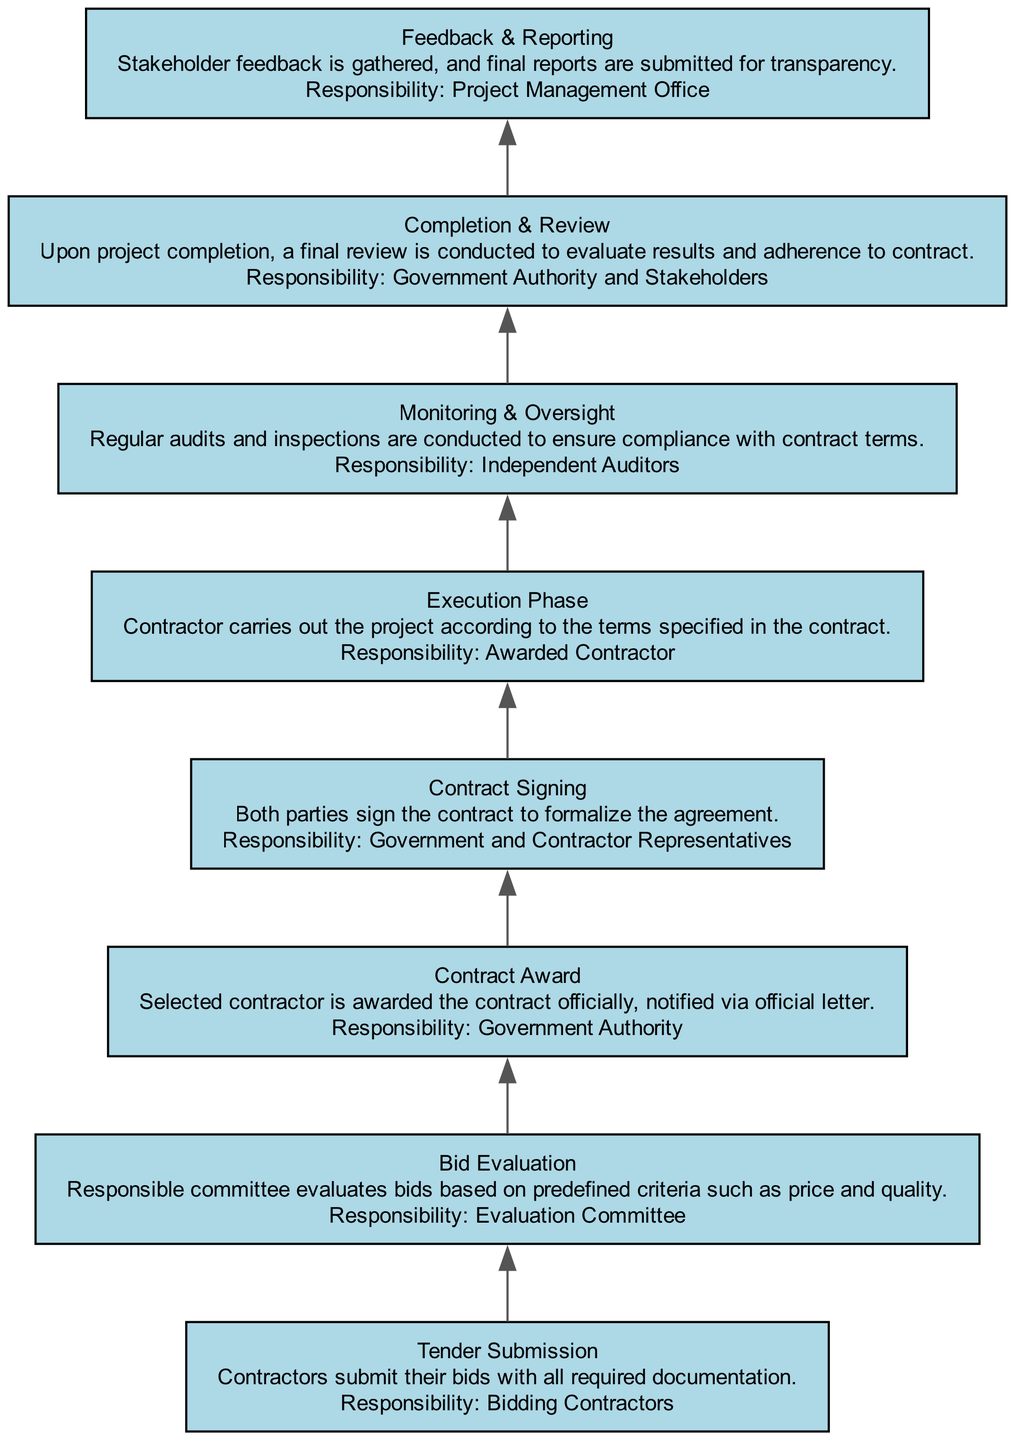What is the first step in the contract process? The diagram starts with "Tender Submission," which indicates that this is the initial step where contractors submit their bids.
Answer: Tender Submission Who is responsible for bid evaluation? The "Evaluation Committee" is designated as responsible for evaluating the bids according to the diagram, indicating their main role in the process.
Answer: Evaluation Committee How many steps are there in the contract process? The diagram lists a total of eight steps in the contract process, starting from "Tender Submission" to "Feedback & Reporting."
Answer: Eight What happens after the contract award? Following the "Contract Award" step, the next step depicted in the diagram is "Contract Signing," showing the sequence of actions that take place.
Answer: Contract Signing What measures are in place to ensure accountability during the execution phase? The "Monitoring & Oversight" step includes regular audits and inspections, indicating the measures taken to ensure that the execution phase remains transparent and accountable.
Answer: Regular audits and inspections Which entity conducts the final review upon project completion? The final review is carried out by "Government Authority and Stakeholders," as detailed in the "Completion & Review" step of the diagram.
Answer: Government Authority and Stakeholders What is the last step in the contract process? The last step, as shown in the diagram, is "Feedback & Reporting," which emphasizes the importance of gathering stakeholder feedback for transparency.
Answer: Feedback & Reporting How does the contract signing relate to the contract award? The "Contract Signing" step comes directly after the "Contract Award" step, indicating that the contract is formally signed after the contractor is selected.
Answer: Directly after What is the main responsibility during the execution phase? The "Awarded Contractor" is identified as having the main responsibility in the execution phase, where they must carry out the project according to the contract terms.
Answer: Awarded Contractor 